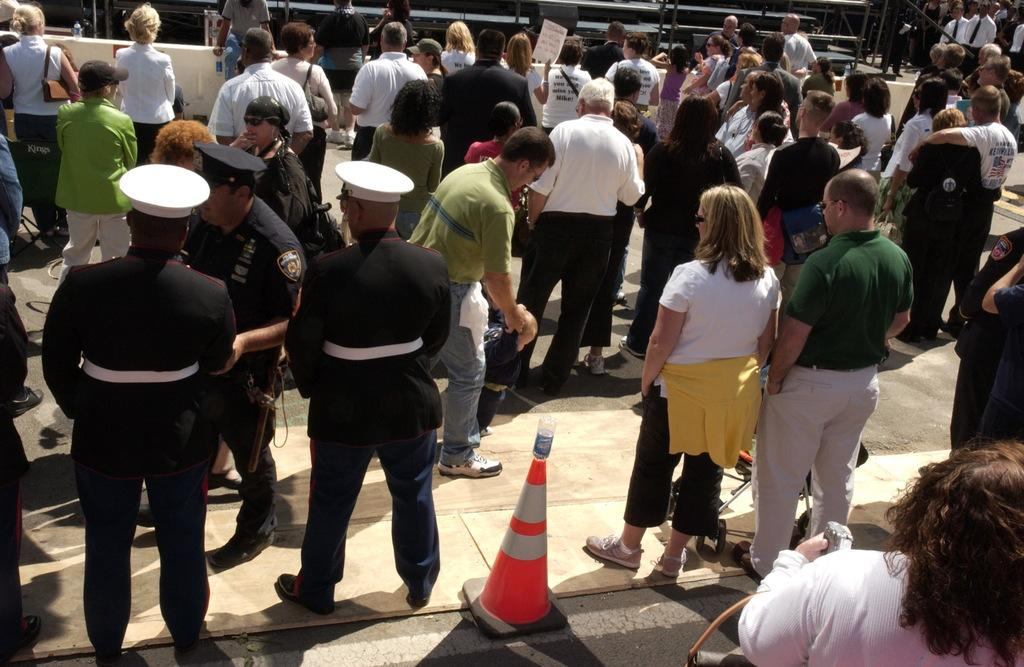What is the main subject of the image? The main subject of the image is a group of people. What are some of the people in the image doing? Some people are standing in the image. What object can be seen in the image besides the people? There is a traffic cone in the image. What type of clothing or accessory can be seen on some of the people? Some people are wearing caps in the image. What type of yam is the queen holding in the image? There is no queen or yam present in the image. What grade is the person in the image currently in? There is no indication of the person's grade or educational level in the image. 